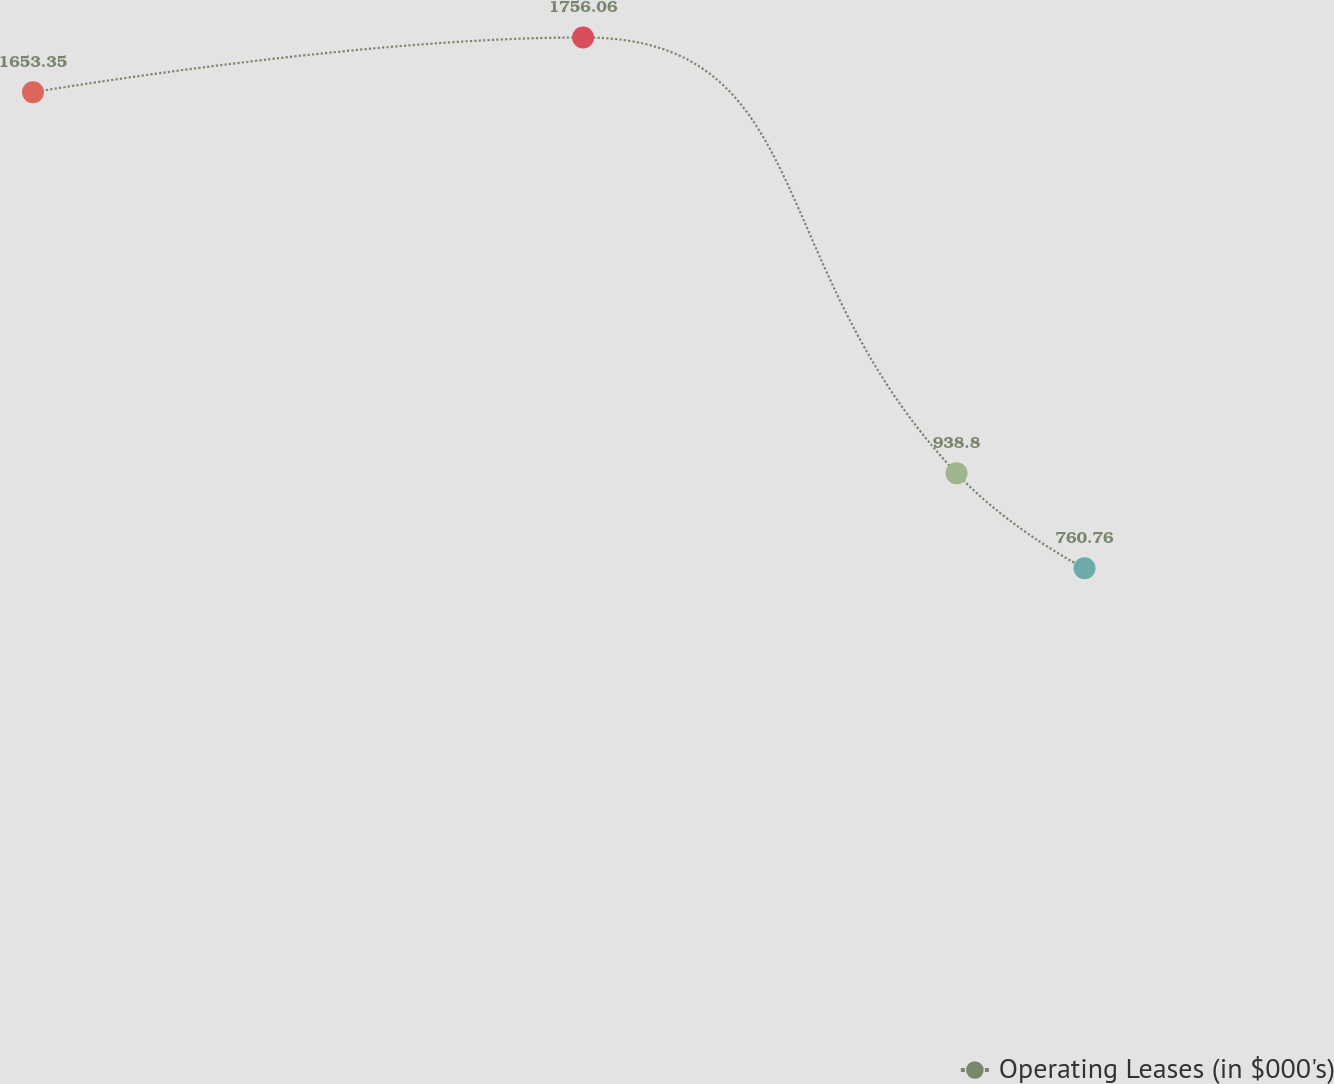Convert chart to OTSL. <chart><loc_0><loc_0><loc_500><loc_500><line_chart><ecel><fcel>Operating Leases (in $000's)<nl><fcel>1859.15<fcel>1653.35<nl><fcel>2080.14<fcel>1756.06<nl><fcel>2230.17<fcel>938.8<nl><fcel>2281.59<fcel>760.76<nl><fcel>2373.38<fcel>658.05<nl></chart> 